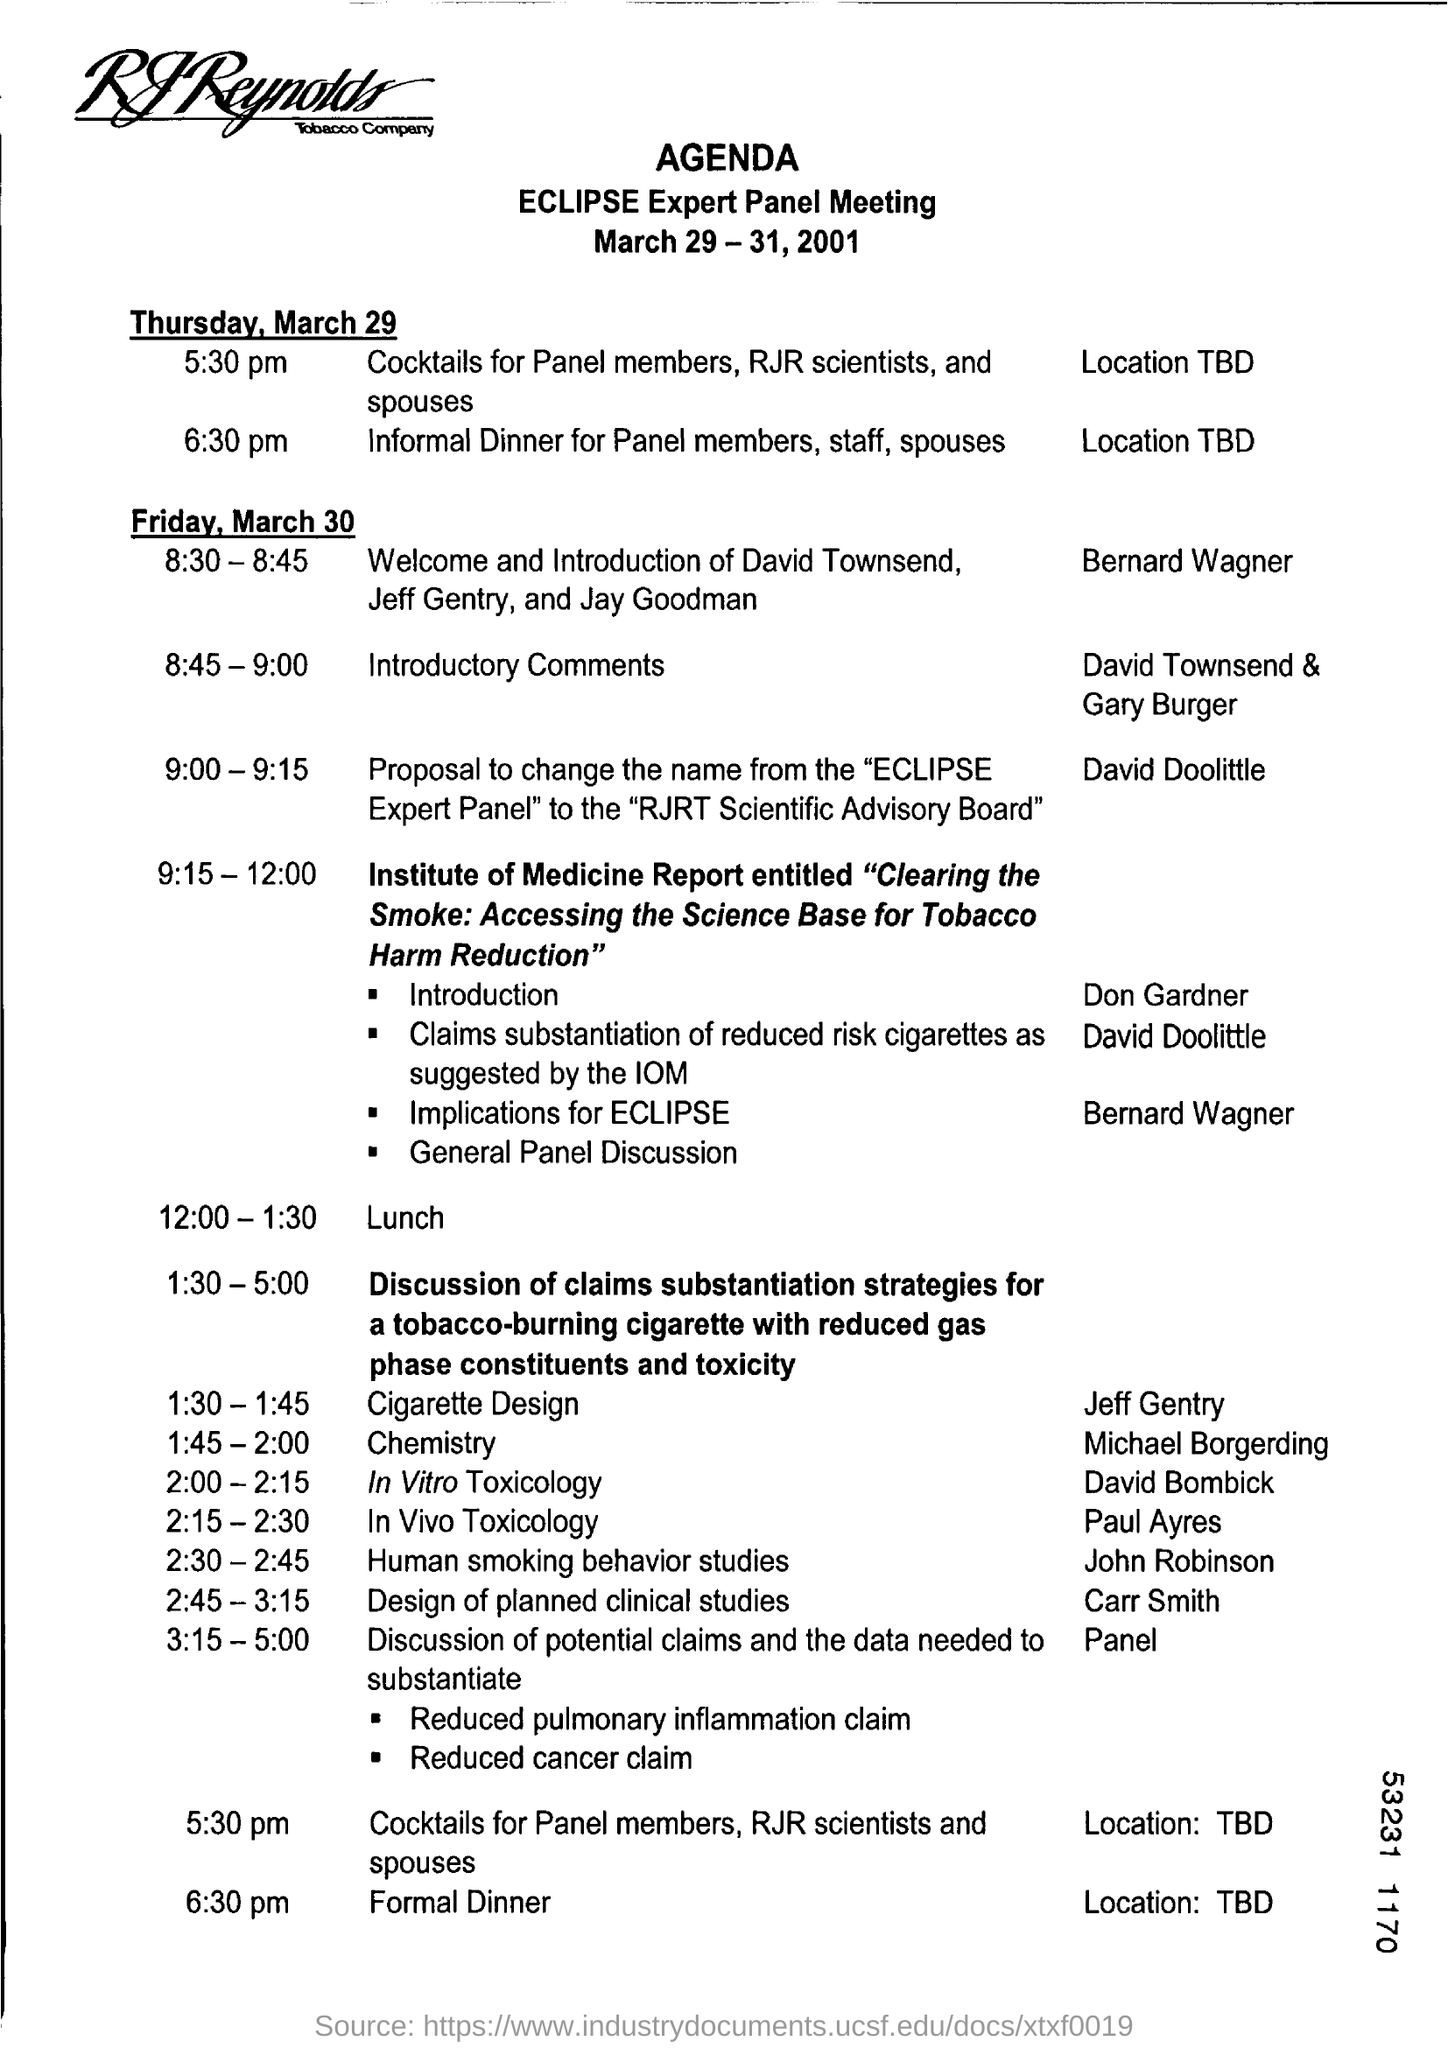Agenda is for which meeting?
Provide a short and direct response. ECLIPSE Expert Panel Meeting. When is the meeting held?
Your response must be concise. March 29-31,2001. What is the location for the informal dinner?
Your answer should be compact. TBD. Who will be giving the introductory comments?
Your answer should be compact. David townsend & Gary Burger. What is the prosposed name for the "eclipse expert panel"?
Provide a short and direct response. RJRT Scientific Advisory Board. What time is the lunch?
Offer a terse response. 12:00 - 1:30. What is the first agenda for friday, march 30?
Ensure brevity in your answer.  Welcome and introduction of david townsend, jeff gentry and jay goodman. 